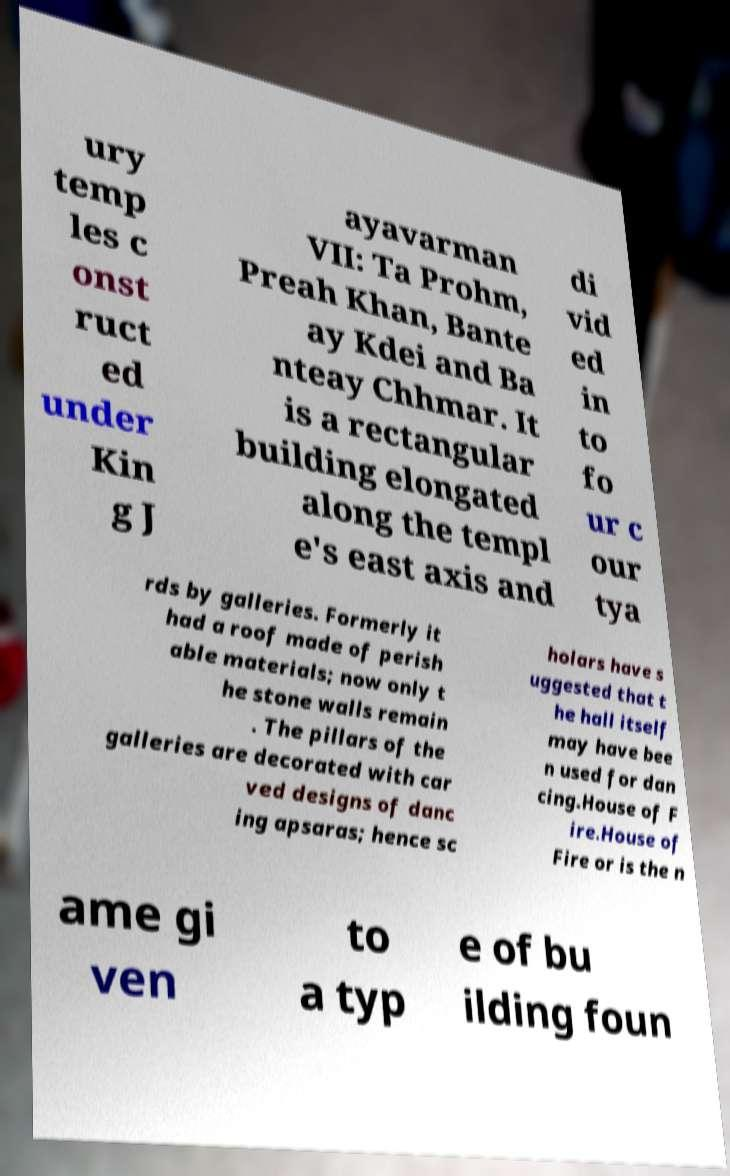Please identify and transcribe the text found in this image. ury temp les c onst ruct ed under Kin g J ayavarman VII: Ta Prohm, Preah Khan, Bante ay Kdei and Ba nteay Chhmar. It is a rectangular building elongated along the templ e's east axis and di vid ed in to fo ur c our tya rds by galleries. Formerly it had a roof made of perish able materials; now only t he stone walls remain . The pillars of the galleries are decorated with car ved designs of danc ing apsaras; hence sc holars have s uggested that t he hall itself may have bee n used for dan cing.House of F ire.House of Fire or is the n ame gi ven to a typ e of bu ilding foun 